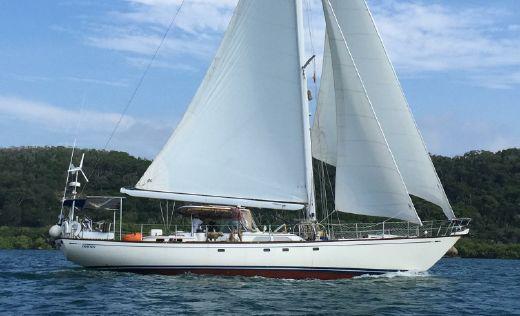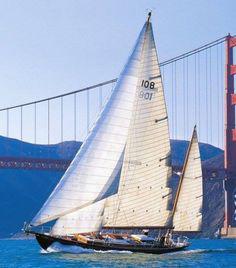The first image is the image on the left, the second image is the image on the right. Considering the images on both sides, is "The sail boat in the right image has three sails engaged." valid? Answer yes or no. No. The first image is the image on the left, the second image is the image on the right. For the images shown, is this caption "One of the boats only has two sails [unfurled]." true? Answer yes or no. No. 